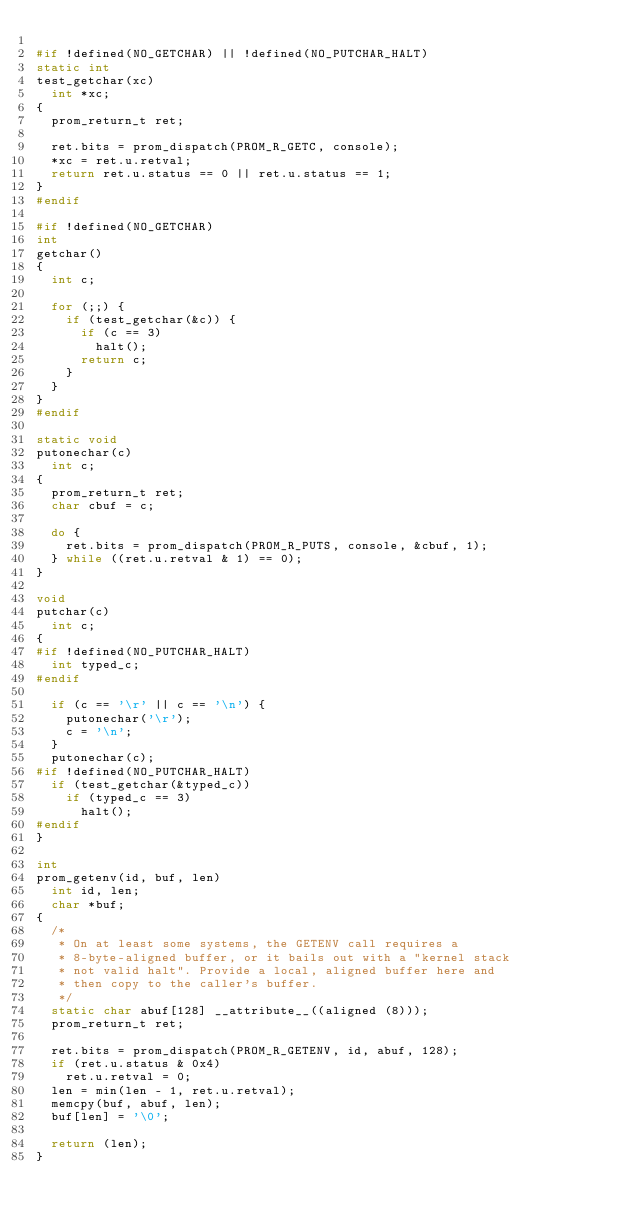<code> <loc_0><loc_0><loc_500><loc_500><_C_>
#if !defined(NO_GETCHAR) || !defined(NO_PUTCHAR_HALT)
static int
test_getchar(xc)
	int *xc;
{
	prom_return_t ret;

	ret.bits = prom_dispatch(PROM_R_GETC, console);
	*xc = ret.u.retval;
	return ret.u.status == 0 || ret.u.status == 1;
}
#endif

#if !defined(NO_GETCHAR)
int
getchar()
{
	int c;

	for (;;) {
		if (test_getchar(&c)) {
			if (c == 3)
				halt();
			return c;
		}
	}
}
#endif

static void
putonechar(c)
	int c;
{
	prom_return_t ret;
	char cbuf = c;

	do {
		ret.bits = prom_dispatch(PROM_R_PUTS, console, &cbuf, 1);
	} while ((ret.u.retval & 1) == 0);
}

void
putchar(c)
	int c;
{
#if !defined(NO_PUTCHAR_HALT)
	int typed_c;
#endif

	if (c == '\r' || c == '\n') {
		putonechar('\r');
		c = '\n';
	}
	putonechar(c);
#if !defined(NO_PUTCHAR_HALT)
	if (test_getchar(&typed_c))
		if (typed_c == 3)
			halt();
#endif
}

int
prom_getenv(id, buf, len)
	int id, len;
	char *buf;
{
	/* 
	 * On at least some systems, the GETENV call requires a
	 * 8-byte-aligned buffer, or it bails out with a "kernel stack
	 * not valid halt". Provide a local, aligned buffer here and
	 * then copy to the caller's buffer.
	 */
	static char abuf[128] __attribute__((aligned (8)));
	prom_return_t ret;

	ret.bits = prom_dispatch(PROM_R_GETENV, id, abuf, 128);
	if (ret.u.status & 0x4)
		ret.u.retval = 0;
	len = min(len - 1, ret.u.retval);
	memcpy(buf, abuf, len);
	buf[len] = '\0';

	return (len);
}
</code> 